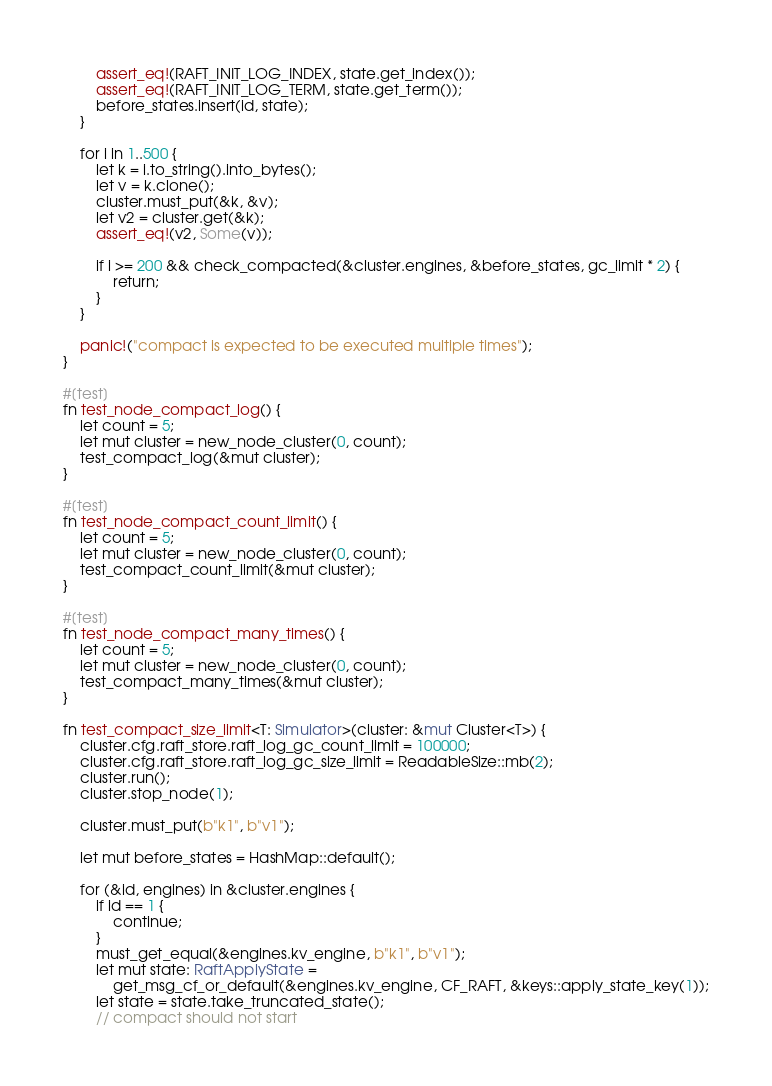Convert code to text. <code><loc_0><loc_0><loc_500><loc_500><_Rust_>        assert_eq!(RAFT_INIT_LOG_INDEX, state.get_index());
        assert_eq!(RAFT_INIT_LOG_TERM, state.get_term());
        before_states.insert(id, state);
    }

    for i in 1..500 {
        let k = i.to_string().into_bytes();
        let v = k.clone();
        cluster.must_put(&k, &v);
        let v2 = cluster.get(&k);
        assert_eq!(v2, Some(v));

        if i >= 200 && check_compacted(&cluster.engines, &before_states, gc_limit * 2) {
            return;
        }
    }

    panic!("compact is expected to be executed multiple times");
}

#[test]
fn test_node_compact_log() {
    let count = 5;
    let mut cluster = new_node_cluster(0, count);
    test_compact_log(&mut cluster);
}

#[test]
fn test_node_compact_count_limit() {
    let count = 5;
    let mut cluster = new_node_cluster(0, count);
    test_compact_count_limit(&mut cluster);
}

#[test]
fn test_node_compact_many_times() {
    let count = 5;
    let mut cluster = new_node_cluster(0, count);
    test_compact_many_times(&mut cluster);
}

fn test_compact_size_limit<T: Simulator>(cluster: &mut Cluster<T>) {
    cluster.cfg.raft_store.raft_log_gc_count_limit = 100000;
    cluster.cfg.raft_store.raft_log_gc_size_limit = ReadableSize::mb(2);
    cluster.run();
    cluster.stop_node(1);

    cluster.must_put(b"k1", b"v1");

    let mut before_states = HashMap::default();

    for (&id, engines) in &cluster.engines {
        if id == 1 {
            continue;
        }
        must_get_equal(&engines.kv_engine, b"k1", b"v1");
        let mut state: RaftApplyState =
            get_msg_cf_or_default(&engines.kv_engine, CF_RAFT, &keys::apply_state_key(1));
        let state = state.take_truncated_state();
        // compact should not start</code> 